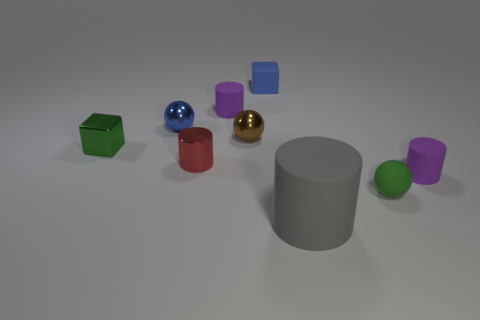Are there any other things that have the same size as the gray cylinder?
Your answer should be compact. No. Are there any metal spheres of the same color as the rubber cube?
Offer a terse response. Yes. Are there any tiny rubber blocks behind the big gray rubber object?
Your answer should be very brief. Yes. How many green cylinders are there?
Give a very brief answer. 0. There is a tiny purple cylinder to the left of the blue rubber thing; what number of blue things are right of it?
Keep it short and to the point. 1. Is the color of the metal cube the same as the tiny ball in front of the small red metallic cylinder?
Provide a short and direct response. Yes. How many tiny red metallic things are the same shape as the green rubber thing?
Provide a short and direct response. 0. What is the material of the purple thing in front of the metallic cylinder?
Give a very brief answer. Rubber. Is the shape of the green object that is on the left side of the big gray cylinder the same as  the brown metallic object?
Offer a terse response. No. Are there any spheres that have the same size as the green metallic cube?
Your answer should be compact. Yes. 